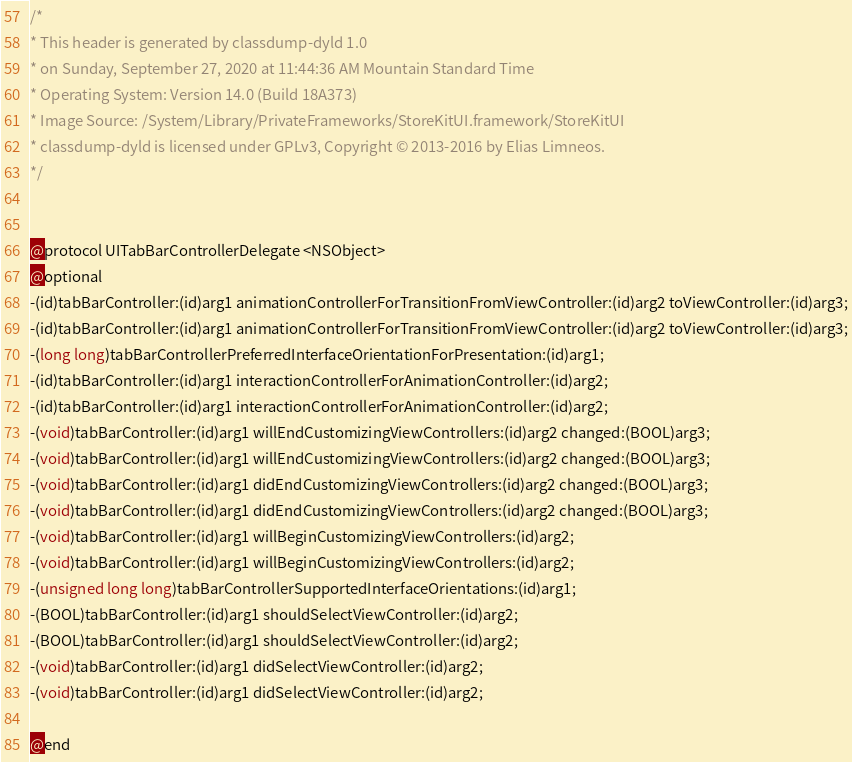Convert code to text. <code><loc_0><loc_0><loc_500><loc_500><_C_>/*
* This header is generated by classdump-dyld 1.0
* on Sunday, September 27, 2020 at 11:44:36 AM Mountain Standard Time
* Operating System: Version 14.0 (Build 18A373)
* Image Source: /System/Library/PrivateFrameworks/StoreKitUI.framework/StoreKitUI
* classdump-dyld is licensed under GPLv3, Copyright © 2013-2016 by Elias Limneos.
*/


@protocol UITabBarControllerDelegate <NSObject>
@optional
-(id)tabBarController:(id)arg1 animationControllerForTransitionFromViewController:(id)arg2 toViewController:(id)arg3;
-(id)tabBarController:(id)arg1 animationControllerForTransitionFromViewController:(id)arg2 toViewController:(id)arg3;
-(long long)tabBarControllerPreferredInterfaceOrientationForPresentation:(id)arg1;
-(id)tabBarController:(id)arg1 interactionControllerForAnimationController:(id)arg2;
-(id)tabBarController:(id)arg1 interactionControllerForAnimationController:(id)arg2;
-(void)tabBarController:(id)arg1 willEndCustomizingViewControllers:(id)arg2 changed:(BOOL)arg3;
-(void)tabBarController:(id)arg1 willEndCustomizingViewControllers:(id)arg2 changed:(BOOL)arg3;
-(void)tabBarController:(id)arg1 didEndCustomizingViewControllers:(id)arg2 changed:(BOOL)arg3;
-(void)tabBarController:(id)arg1 didEndCustomizingViewControllers:(id)arg2 changed:(BOOL)arg3;
-(void)tabBarController:(id)arg1 willBeginCustomizingViewControllers:(id)arg2;
-(void)tabBarController:(id)arg1 willBeginCustomizingViewControllers:(id)arg2;
-(unsigned long long)tabBarControllerSupportedInterfaceOrientations:(id)arg1;
-(BOOL)tabBarController:(id)arg1 shouldSelectViewController:(id)arg2;
-(BOOL)tabBarController:(id)arg1 shouldSelectViewController:(id)arg2;
-(void)tabBarController:(id)arg1 didSelectViewController:(id)arg2;
-(void)tabBarController:(id)arg1 didSelectViewController:(id)arg2;

@end

</code> 